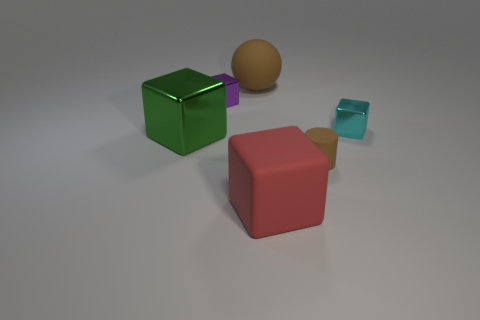Subtract 1 cubes. How many cubes are left? 3 Subtract all small cyan cubes. How many cubes are left? 3 Add 2 big shiny objects. How many objects exist? 8 Subtract all yellow blocks. Subtract all blue spheres. How many blocks are left? 4 Subtract all cylinders. How many objects are left? 5 Subtract 0 green cylinders. How many objects are left? 6 Subtract all large red cylinders. Subtract all tiny cyan shiny blocks. How many objects are left? 5 Add 2 tiny cyan objects. How many tiny cyan objects are left? 3 Add 3 shiny spheres. How many shiny spheres exist? 3 